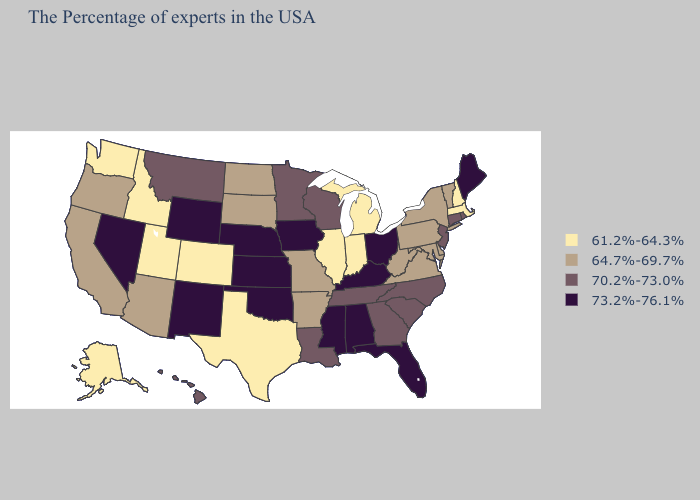Among the states that border Louisiana , which have the highest value?
Write a very short answer. Mississippi. What is the highest value in states that border Tennessee?
Give a very brief answer. 73.2%-76.1%. How many symbols are there in the legend?
Concise answer only. 4. What is the highest value in the Northeast ?
Write a very short answer. 73.2%-76.1%. What is the value of Alaska?
Be succinct. 61.2%-64.3%. Name the states that have a value in the range 73.2%-76.1%?
Keep it brief. Maine, Ohio, Florida, Kentucky, Alabama, Mississippi, Iowa, Kansas, Nebraska, Oklahoma, Wyoming, New Mexico, Nevada. What is the value of South Dakota?
Keep it brief. 64.7%-69.7%. What is the value of Oregon?
Keep it brief. 64.7%-69.7%. Among the states that border South Dakota , does North Dakota have the highest value?
Answer briefly. No. What is the value of Wyoming?
Write a very short answer. 73.2%-76.1%. Name the states that have a value in the range 61.2%-64.3%?
Write a very short answer. Massachusetts, New Hampshire, Michigan, Indiana, Illinois, Texas, Colorado, Utah, Idaho, Washington, Alaska. What is the value of Montana?
Quick response, please. 70.2%-73.0%. Does Texas have the lowest value in the USA?
Write a very short answer. Yes. What is the value of Nevada?
Give a very brief answer. 73.2%-76.1%. Name the states that have a value in the range 70.2%-73.0%?
Short answer required. Rhode Island, Connecticut, New Jersey, North Carolina, South Carolina, Georgia, Tennessee, Wisconsin, Louisiana, Minnesota, Montana, Hawaii. 